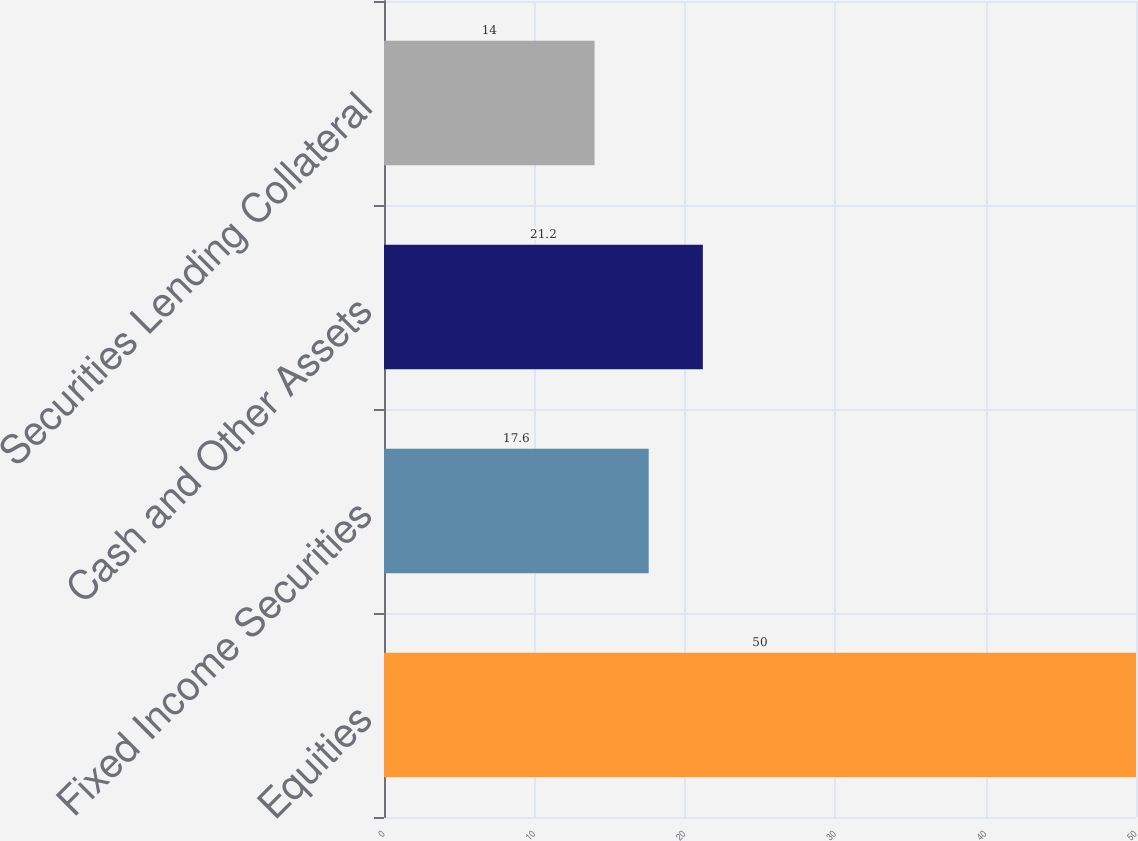Convert chart to OTSL. <chart><loc_0><loc_0><loc_500><loc_500><bar_chart><fcel>Equities<fcel>Fixed Income Securities<fcel>Cash and Other Assets<fcel>Securities Lending Collateral<nl><fcel>50<fcel>17.6<fcel>21.2<fcel>14<nl></chart> 